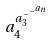<formula> <loc_0><loc_0><loc_500><loc_500>a _ { 4 } ^ { a _ { 3 } ^ { - ^ { - ^ { a _ { n } } } } }</formula> 